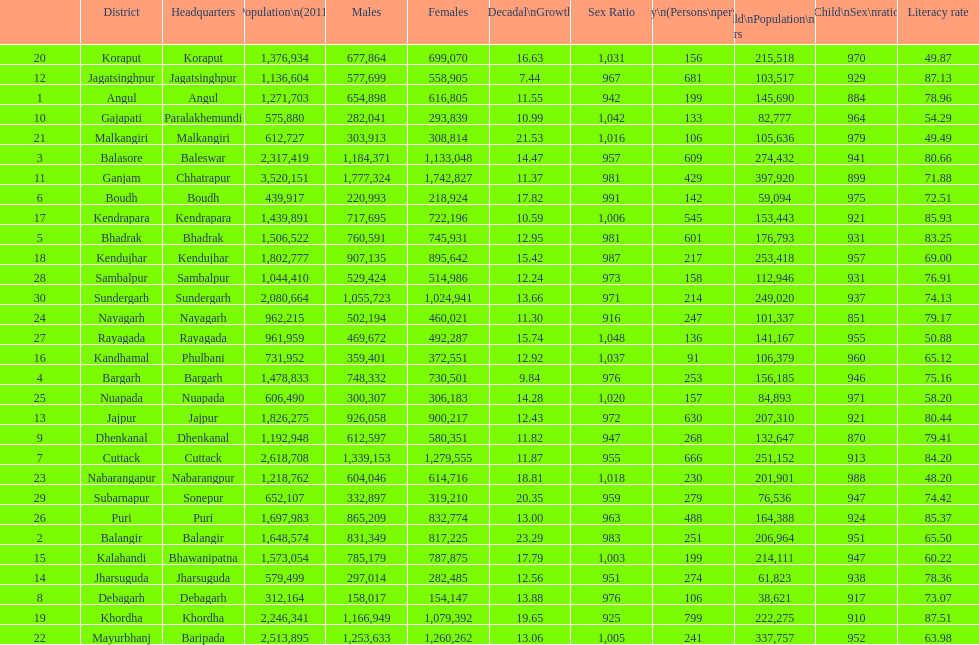Which district had the most people per km? Khordha. 